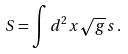<formula> <loc_0><loc_0><loc_500><loc_500>S = \int d ^ { 2 } x \sqrt { g } \, s \, .</formula> 